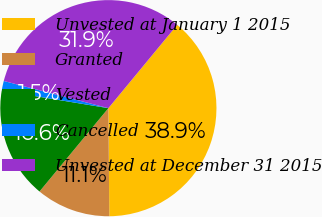<chart> <loc_0><loc_0><loc_500><loc_500><pie_chart><fcel>Unvested at January 1 2015<fcel>Granted<fcel>Vested<fcel>Cancelled<fcel>Unvested at December 31 2015<nl><fcel>38.87%<fcel>11.13%<fcel>16.61%<fcel>1.45%<fcel>31.94%<nl></chart> 